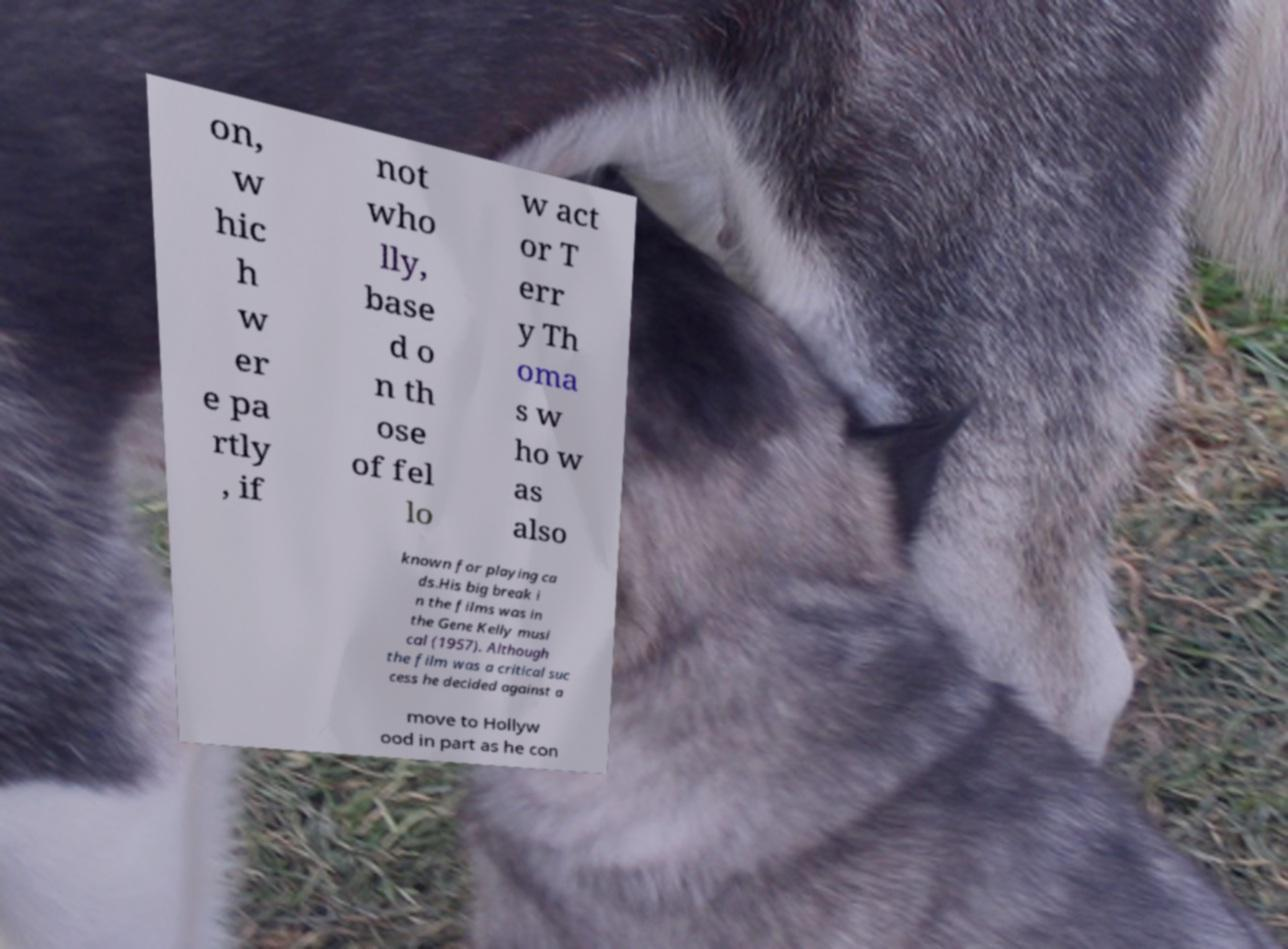Please identify and transcribe the text found in this image. on, w hic h w er e pa rtly , if not who lly, base d o n th ose of fel lo w act or T err y Th oma s w ho w as also known for playing ca ds.His big break i n the films was in the Gene Kelly musi cal (1957). Although the film was a critical suc cess he decided against a move to Hollyw ood in part as he con 